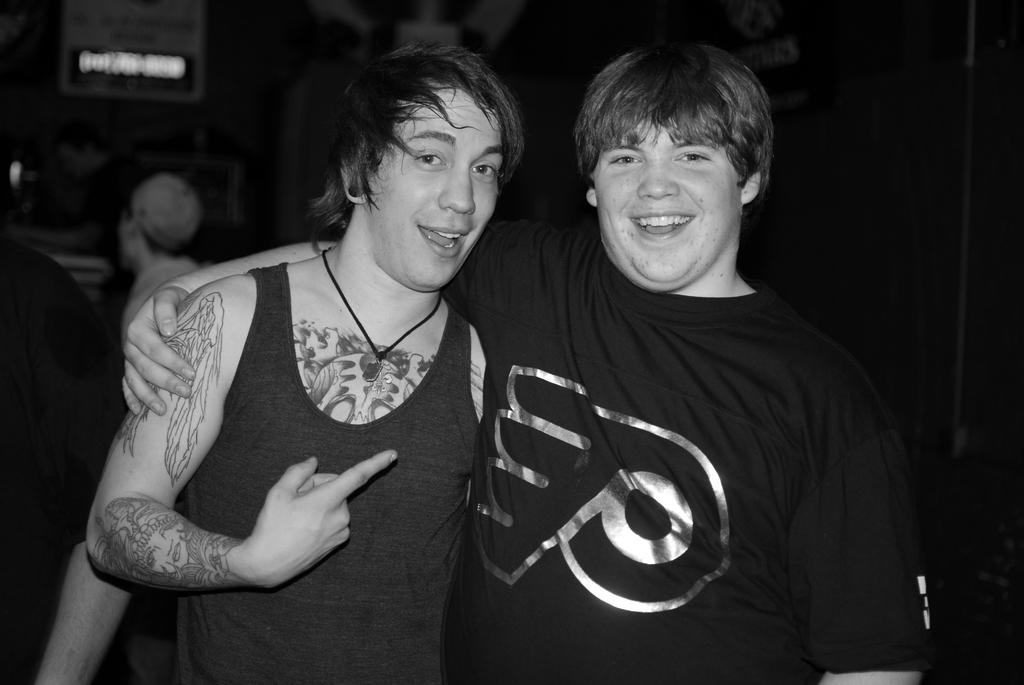What is the color scheme of the image? The image is black and white. How many people are visible in the image? There are two people standing in the image. What can be observed about the background of the image? The background of the image is dark. Are there any other people in the image besides the two standing in the foreground? Yes, there are people standing in the background of the image. What type of deer can be seen in the image? There are no deer present in the image. What health advice is being given in the image? The image does not depict any health advice or recommendations. 